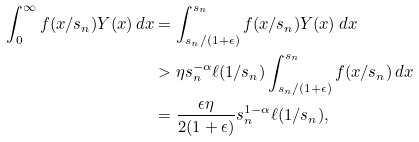<formula> <loc_0><loc_0><loc_500><loc_500>\int _ { 0 } ^ { \infty } f ( x / s _ { n } ) Y ( x ) \, d x & = \int _ { s _ { n } / ( 1 + \epsilon ) } ^ { s _ { n } } f ( x / s _ { n } ) Y ( x ) \, d x \\ & > \eta s _ { n } ^ { - \alpha } \ell ( 1 / s _ { n } ) \int _ { s _ { n } / ( 1 + \epsilon ) } ^ { s _ { n } } f ( x / s _ { n } ) \, d x \\ & = \frac { \epsilon \eta } { 2 ( 1 + \epsilon ) } s _ { n } ^ { 1 - \alpha } \ell ( 1 / s _ { n } ) ,</formula> 